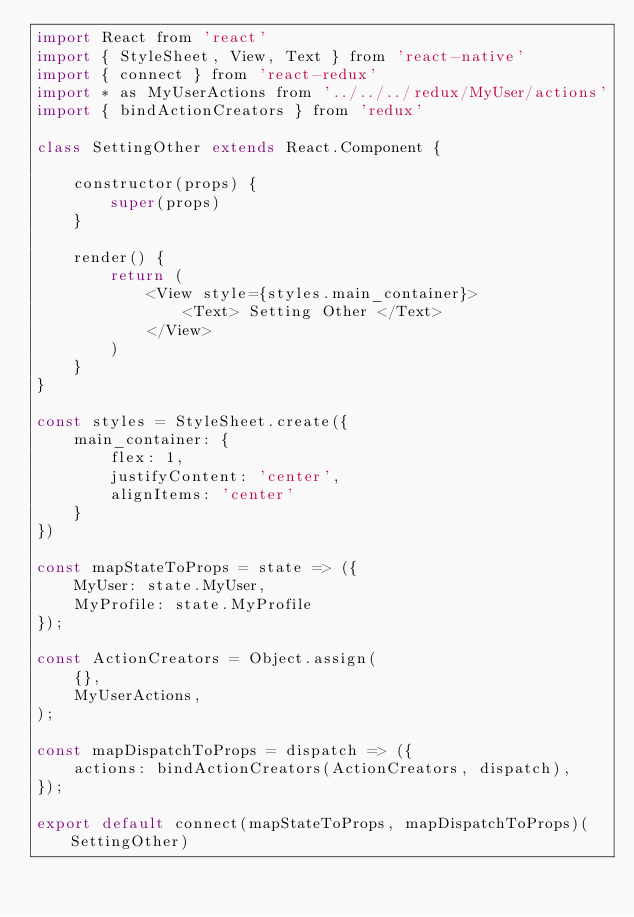<code> <loc_0><loc_0><loc_500><loc_500><_JavaScript_>import React from 'react'
import { StyleSheet, View, Text } from 'react-native'
import { connect } from 'react-redux'
import * as MyUserActions from '../../../redux/MyUser/actions'
import { bindActionCreators } from 'redux'

class SettingOther extends React.Component {

    constructor(props) {
        super(props)
    }

    render() {
        return (
            <View style={styles.main_container}>
                <Text> Setting Other </Text>
            </View>
        )
    }
}

const styles = StyleSheet.create({
    main_container: {
        flex: 1,
        justifyContent: 'center',
        alignItems: 'center'
    }
})

const mapStateToProps = state => ({
    MyUser: state.MyUser,
    MyProfile: state.MyProfile
});

const ActionCreators = Object.assign(
    {},
    MyUserActions,
);

const mapDispatchToProps = dispatch => ({
    actions: bindActionCreators(ActionCreators, dispatch),
});

export default connect(mapStateToProps, mapDispatchToProps)(SettingOther)</code> 